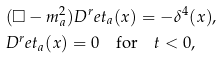<formula> <loc_0><loc_0><loc_500><loc_500>& ( \Box - m _ { a } ^ { 2 } ) D ^ { r } e t _ { a } ( x ) = - \delta ^ { 4 } ( x ) , \\ & D ^ { r } e t _ { a } ( x ) = 0 \quad \text {for} \quad t < 0 ,</formula> 